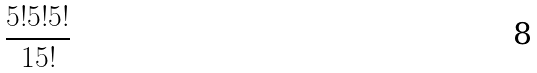<formula> <loc_0><loc_0><loc_500><loc_500>\frac { 5 ! 5 ! 5 ! } { 1 5 ! }</formula> 